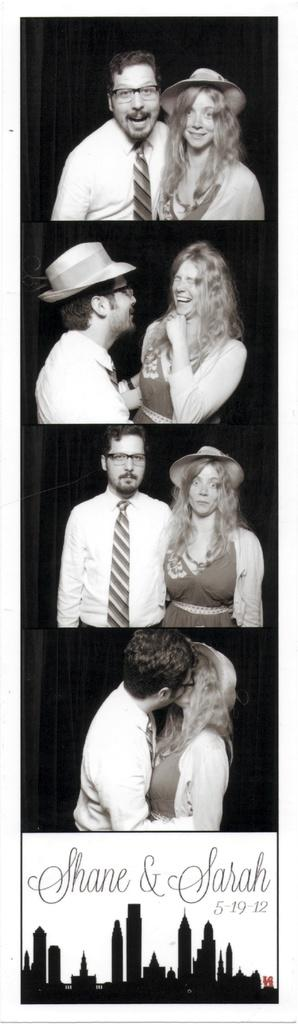What types of people are in the image? There are men and women in the image. Where are the men and women located? The men and women are standing on the floor. What are the men and women doing in the image? The men and women are laughing. What can be seen at the bottom of the image? There are buildings at the bottom of the image. Can you see any blood on the floor where the men and women are standing? There is no blood visible on the floor in the image. What type of answer can be seen in the image? There is no answer present in the image; it features men and women standing and laughing. 